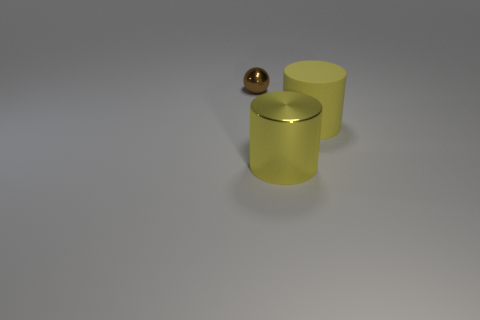Add 1 red matte balls. How many objects exist? 4 Subtract all cylinders. How many objects are left? 1 Add 1 brown spheres. How many brown spheres are left? 2 Add 1 tiny objects. How many tiny objects exist? 2 Subtract 0 blue balls. How many objects are left? 3 Subtract all red rubber balls. Subtract all yellow cylinders. How many objects are left? 1 